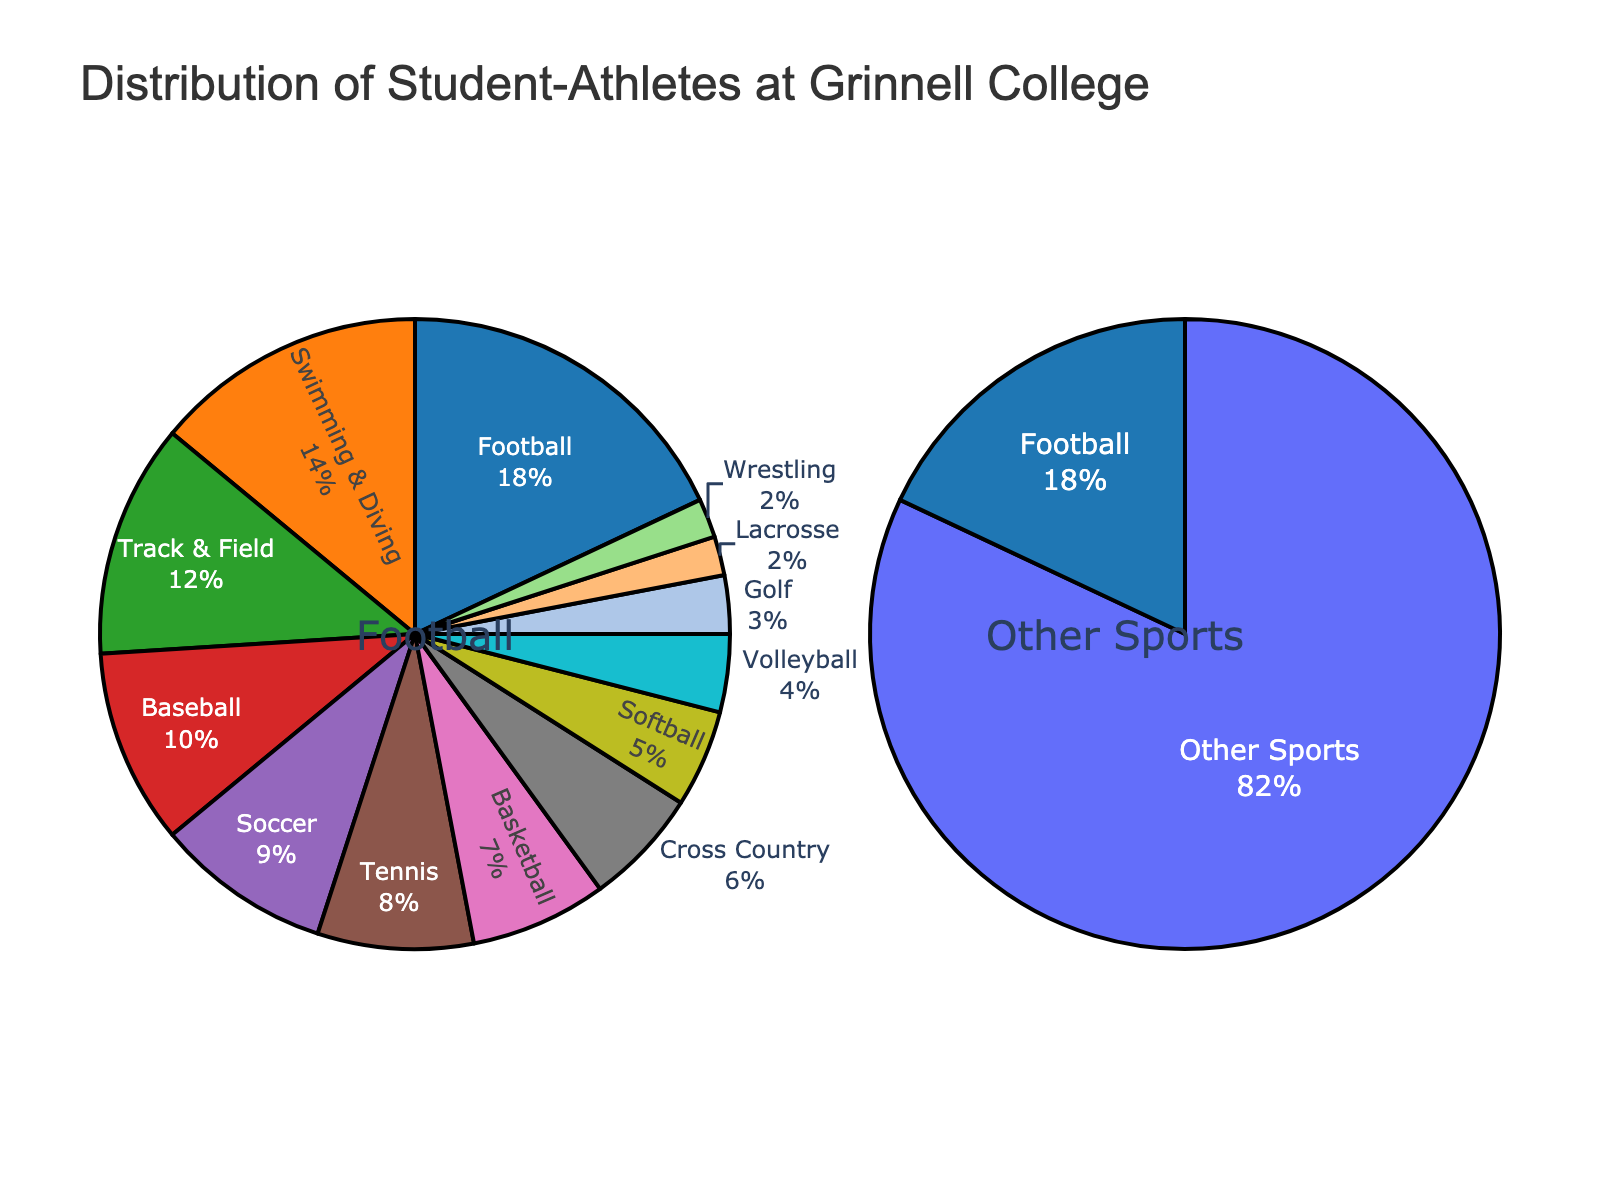What sport has the largest proportion of student-athletes at Grinnell College? By looking at the pie chart, it can be observed that football has the largest proportion.
Answer: Football Which sport has a larger proportion of student-athletes, Tennis or Basketball? By referring to the chart, Tennis has 8% while Basketball has 7%. Therefore, Tennis has a larger proportion.
Answer: Tennis What is the combined proportion of student-athletes in Soccer and Swimming & Diving? From the chart, Soccer has 9% and Swimming & Diving has 14%. Adding these values gives 9% + 14% = 23%.
Answer: 23% Which sport has the smallest proportion of student-athletes? The sport with the smallest proportion according to the chart is Lacrosse and Wrestling, both at 2%.
Answer: Lacrosse and Wrestling How much greater is the proportion of student-athletes in Football compared to Softball? Football has a proportion of 18%, and Softball has 5%. The difference is 18% - 5% = 13%.
Answer: 13% What is the difference in proportion between Swimming & Diving and Track & Field? Swimming & Diving has 14% and Track & Field has 12%. The difference is 14% - 12% = 2%.
Answer: 2% What is the average proportion of student-athletes in Soccer, Baseball, and Tennis? The proportions are Soccer 9%, Baseball 10%, and Tennis 8%. The average is (9% + 10% + 8%) / 3 = 9%.
Answer: 9% What proportion of student-athletes participate in sports other than Football? Football has 18%, so the remaining proportion is 100% - 18% = 82%.
Answer: 82% Is the number of student-athletes in Basketball closer to those in Tennis or Track & Field? Basketball has 7%, Tennis has 8%, and Track & Field has 12%. The difference between Basketball and Tennis is 1%, while the difference between Basketball and Track & Field is 5%. Therefore, it is closer to Tennis.
Answer: Tennis Which sports have a proportion of student-athletes greater than or equal to 10%? Referring to the chart, Football (18%), Swimming & Diving (14%), Track & Field (12%), and Baseball (10%) meet this criterion.
Answer: Football, Swimming & Diving, Track & Field, Baseball 